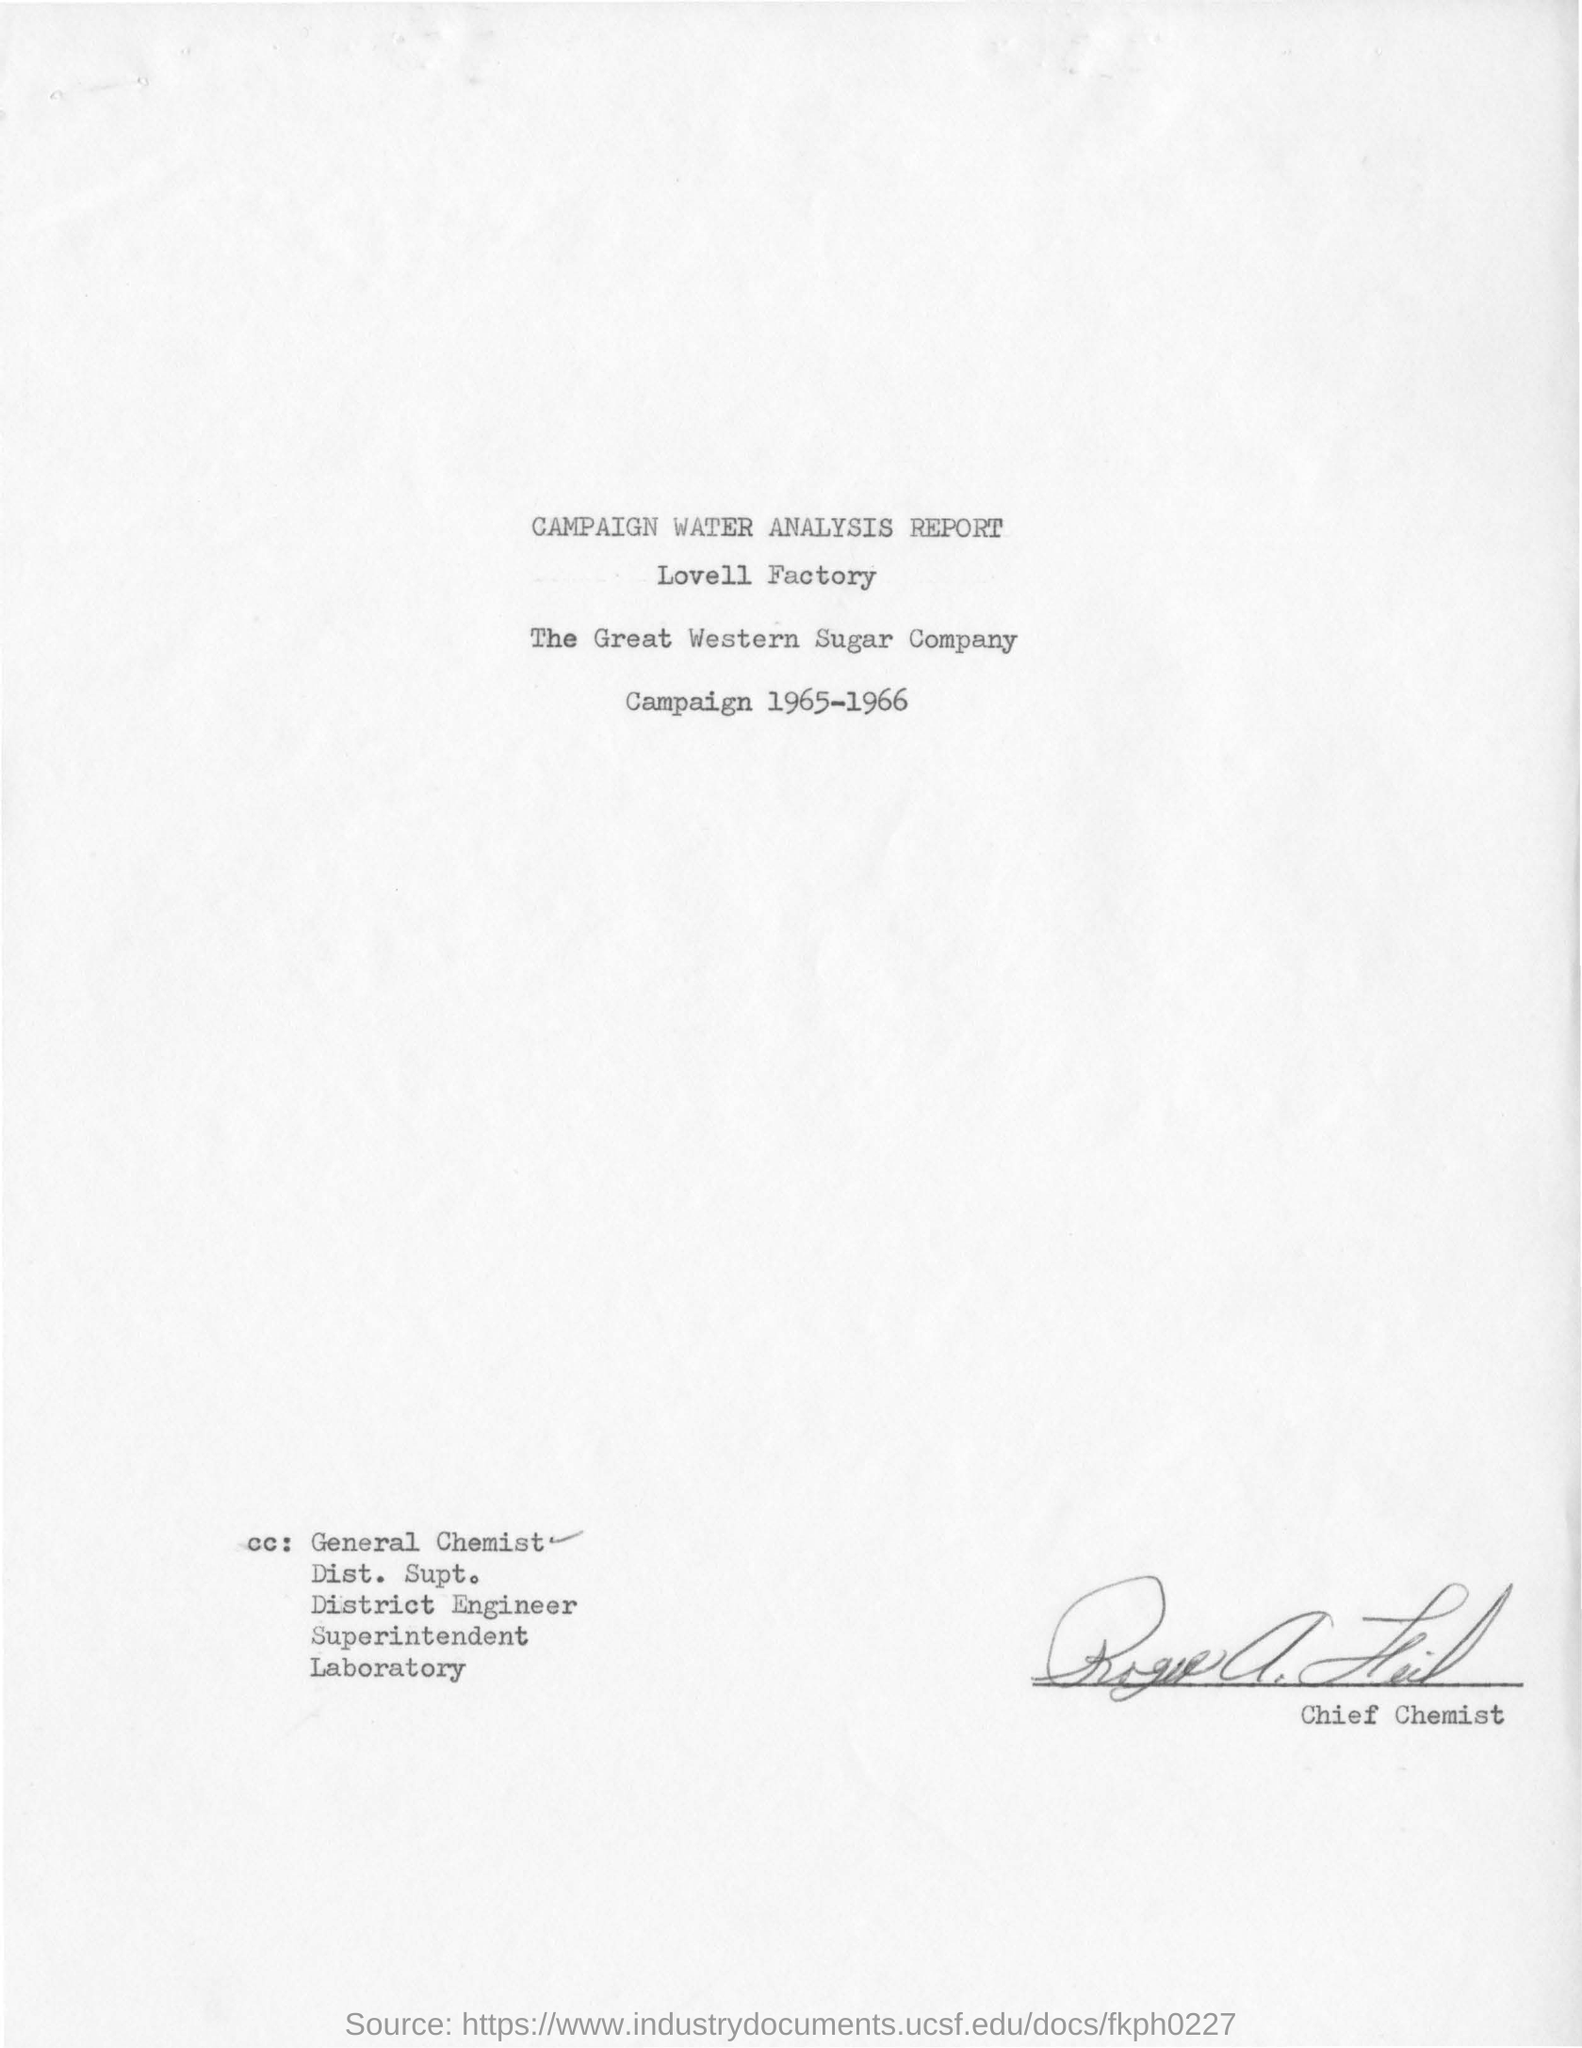What is the factory name ?
Keep it short and to the point. Lovell Factory. What is the year mentioned in the top of the document ?
Keep it short and to the point. 1965-1966. 